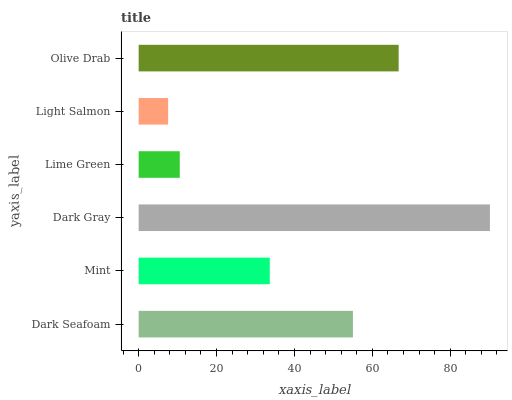Is Light Salmon the minimum?
Answer yes or no. Yes. Is Dark Gray the maximum?
Answer yes or no. Yes. Is Mint the minimum?
Answer yes or no. No. Is Mint the maximum?
Answer yes or no. No. Is Dark Seafoam greater than Mint?
Answer yes or no. Yes. Is Mint less than Dark Seafoam?
Answer yes or no. Yes. Is Mint greater than Dark Seafoam?
Answer yes or no. No. Is Dark Seafoam less than Mint?
Answer yes or no. No. Is Dark Seafoam the high median?
Answer yes or no. Yes. Is Mint the low median?
Answer yes or no. Yes. Is Lime Green the high median?
Answer yes or no. No. Is Dark Seafoam the low median?
Answer yes or no. No. 